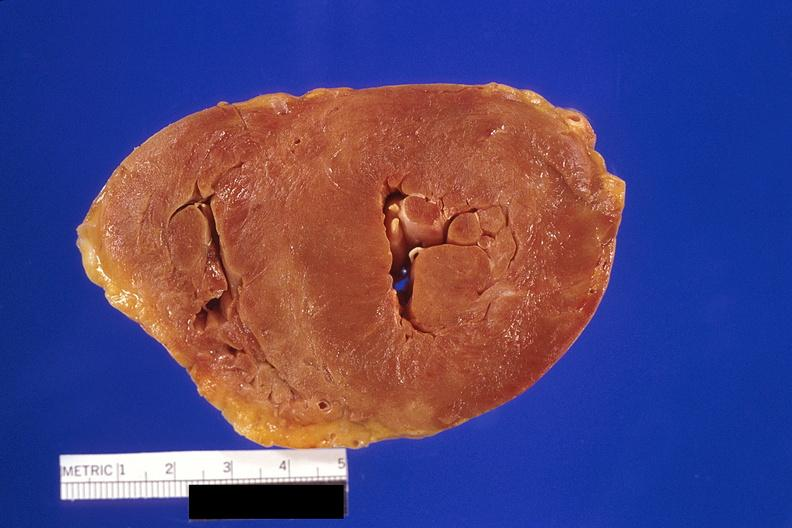what left ventricular hypertrophy?
Answer the question using a single word or phrase. Amyloidosis 